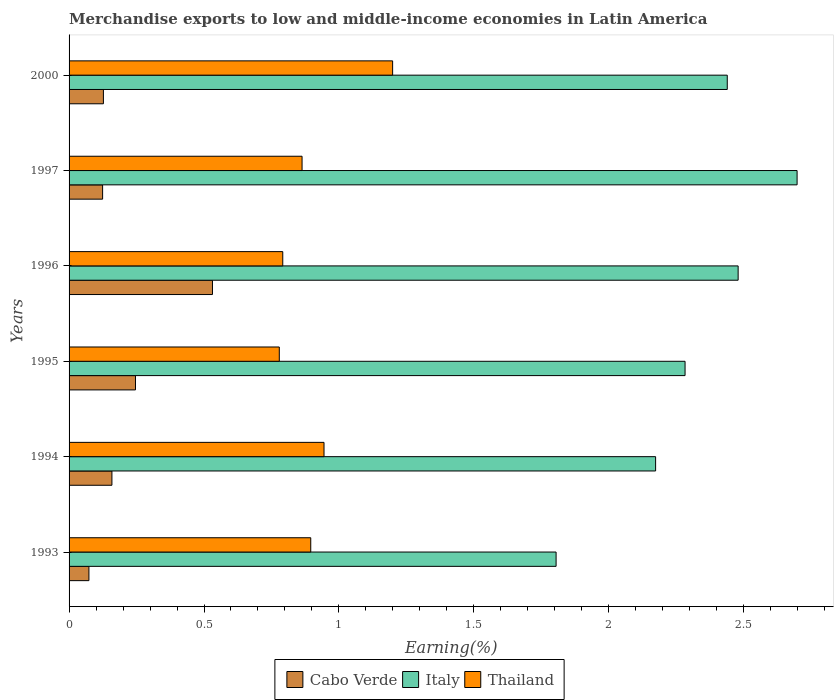How many bars are there on the 1st tick from the top?
Make the answer very short. 3. How many bars are there on the 6th tick from the bottom?
Your answer should be compact. 3. What is the label of the 6th group of bars from the top?
Ensure brevity in your answer.  1993. What is the percentage of amount earned from merchandise exports in Italy in 1996?
Your answer should be very brief. 2.48. Across all years, what is the maximum percentage of amount earned from merchandise exports in Italy?
Your answer should be compact. 2.7. Across all years, what is the minimum percentage of amount earned from merchandise exports in Cabo Verde?
Give a very brief answer. 0.07. In which year was the percentage of amount earned from merchandise exports in Thailand maximum?
Ensure brevity in your answer.  2000. In which year was the percentage of amount earned from merchandise exports in Italy minimum?
Give a very brief answer. 1993. What is the total percentage of amount earned from merchandise exports in Italy in the graph?
Provide a short and direct response. 13.88. What is the difference between the percentage of amount earned from merchandise exports in Cabo Verde in 1996 and that in 2000?
Your answer should be very brief. 0.4. What is the difference between the percentage of amount earned from merchandise exports in Italy in 1994 and the percentage of amount earned from merchandise exports in Cabo Verde in 2000?
Keep it short and to the point. 2.05. What is the average percentage of amount earned from merchandise exports in Cabo Verde per year?
Ensure brevity in your answer.  0.21. In the year 2000, what is the difference between the percentage of amount earned from merchandise exports in Italy and percentage of amount earned from merchandise exports in Cabo Verde?
Ensure brevity in your answer.  2.31. What is the ratio of the percentage of amount earned from merchandise exports in Cabo Verde in 1996 to that in 2000?
Offer a terse response. 4.18. Is the difference between the percentage of amount earned from merchandise exports in Italy in 1994 and 2000 greater than the difference between the percentage of amount earned from merchandise exports in Cabo Verde in 1994 and 2000?
Give a very brief answer. No. What is the difference between the highest and the second highest percentage of amount earned from merchandise exports in Cabo Verde?
Offer a very short reply. 0.29. What is the difference between the highest and the lowest percentage of amount earned from merchandise exports in Thailand?
Make the answer very short. 0.42. In how many years, is the percentage of amount earned from merchandise exports in Italy greater than the average percentage of amount earned from merchandise exports in Italy taken over all years?
Keep it short and to the point. 3. Is it the case that in every year, the sum of the percentage of amount earned from merchandise exports in Cabo Verde and percentage of amount earned from merchandise exports in Italy is greater than the percentage of amount earned from merchandise exports in Thailand?
Make the answer very short. Yes. Are all the bars in the graph horizontal?
Your answer should be very brief. Yes. Are the values on the major ticks of X-axis written in scientific E-notation?
Keep it short and to the point. No. What is the title of the graph?
Your answer should be compact. Merchandise exports to low and middle-income economies in Latin America. What is the label or title of the X-axis?
Your answer should be compact. Earning(%). What is the label or title of the Y-axis?
Make the answer very short. Years. What is the Earning(%) in Cabo Verde in 1993?
Ensure brevity in your answer.  0.07. What is the Earning(%) of Italy in 1993?
Provide a short and direct response. 1.8. What is the Earning(%) in Thailand in 1993?
Provide a succinct answer. 0.9. What is the Earning(%) of Cabo Verde in 1994?
Give a very brief answer. 0.16. What is the Earning(%) in Italy in 1994?
Give a very brief answer. 2.17. What is the Earning(%) of Thailand in 1994?
Provide a succinct answer. 0.94. What is the Earning(%) in Cabo Verde in 1995?
Your response must be concise. 0.25. What is the Earning(%) in Italy in 1995?
Offer a very short reply. 2.28. What is the Earning(%) in Thailand in 1995?
Keep it short and to the point. 0.78. What is the Earning(%) in Cabo Verde in 1996?
Provide a succinct answer. 0.53. What is the Earning(%) in Italy in 1996?
Offer a very short reply. 2.48. What is the Earning(%) of Thailand in 1996?
Offer a very short reply. 0.79. What is the Earning(%) in Cabo Verde in 1997?
Offer a very short reply. 0.12. What is the Earning(%) of Italy in 1997?
Your response must be concise. 2.7. What is the Earning(%) of Thailand in 1997?
Your answer should be very brief. 0.86. What is the Earning(%) in Cabo Verde in 2000?
Make the answer very short. 0.13. What is the Earning(%) in Italy in 2000?
Make the answer very short. 2.44. What is the Earning(%) in Thailand in 2000?
Make the answer very short. 1.2. Across all years, what is the maximum Earning(%) in Cabo Verde?
Offer a very short reply. 0.53. Across all years, what is the maximum Earning(%) of Italy?
Offer a terse response. 2.7. Across all years, what is the maximum Earning(%) of Thailand?
Provide a short and direct response. 1.2. Across all years, what is the minimum Earning(%) in Cabo Verde?
Offer a terse response. 0.07. Across all years, what is the minimum Earning(%) of Italy?
Keep it short and to the point. 1.8. Across all years, what is the minimum Earning(%) in Thailand?
Your response must be concise. 0.78. What is the total Earning(%) in Cabo Verde in the graph?
Give a very brief answer. 1.26. What is the total Earning(%) in Italy in the graph?
Offer a very short reply. 13.88. What is the total Earning(%) in Thailand in the graph?
Your answer should be very brief. 5.47. What is the difference between the Earning(%) of Cabo Verde in 1993 and that in 1994?
Give a very brief answer. -0.09. What is the difference between the Earning(%) in Italy in 1993 and that in 1994?
Your answer should be compact. -0.37. What is the difference between the Earning(%) of Thailand in 1993 and that in 1994?
Keep it short and to the point. -0.05. What is the difference between the Earning(%) in Cabo Verde in 1993 and that in 1995?
Offer a very short reply. -0.17. What is the difference between the Earning(%) of Italy in 1993 and that in 1995?
Provide a short and direct response. -0.48. What is the difference between the Earning(%) of Thailand in 1993 and that in 1995?
Your answer should be very brief. 0.12. What is the difference between the Earning(%) in Cabo Verde in 1993 and that in 1996?
Give a very brief answer. -0.46. What is the difference between the Earning(%) of Italy in 1993 and that in 1996?
Ensure brevity in your answer.  -0.67. What is the difference between the Earning(%) in Thailand in 1993 and that in 1996?
Give a very brief answer. 0.1. What is the difference between the Earning(%) of Cabo Verde in 1993 and that in 1997?
Make the answer very short. -0.05. What is the difference between the Earning(%) in Italy in 1993 and that in 1997?
Provide a short and direct response. -0.89. What is the difference between the Earning(%) in Thailand in 1993 and that in 1997?
Make the answer very short. 0.03. What is the difference between the Earning(%) of Cabo Verde in 1993 and that in 2000?
Ensure brevity in your answer.  -0.05. What is the difference between the Earning(%) in Italy in 1993 and that in 2000?
Keep it short and to the point. -0.63. What is the difference between the Earning(%) in Thailand in 1993 and that in 2000?
Your response must be concise. -0.3. What is the difference between the Earning(%) of Cabo Verde in 1994 and that in 1995?
Your response must be concise. -0.09. What is the difference between the Earning(%) in Italy in 1994 and that in 1995?
Your answer should be very brief. -0.11. What is the difference between the Earning(%) of Thailand in 1994 and that in 1995?
Give a very brief answer. 0.17. What is the difference between the Earning(%) in Cabo Verde in 1994 and that in 1996?
Offer a terse response. -0.37. What is the difference between the Earning(%) of Italy in 1994 and that in 1996?
Provide a short and direct response. -0.31. What is the difference between the Earning(%) of Thailand in 1994 and that in 1996?
Provide a short and direct response. 0.15. What is the difference between the Earning(%) in Cabo Verde in 1994 and that in 1997?
Offer a terse response. 0.03. What is the difference between the Earning(%) of Italy in 1994 and that in 1997?
Provide a succinct answer. -0.52. What is the difference between the Earning(%) of Thailand in 1994 and that in 1997?
Ensure brevity in your answer.  0.08. What is the difference between the Earning(%) of Cabo Verde in 1994 and that in 2000?
Your answer should be compact. 0.03. What is the difference between the Earning(%) of Italy in 1994 and that in 2000?
Your answer should be compact. -0.27. What is the difference between the Earning(%) in Thailand in 1994 and that in 2000?
Keep it short and to the point. -0.25. What is the difference between the Earning(%) of Cabo Verde in 1995 and that in 1996?
Provide a short and direct response. -0.29. What is the difference between the Earning(%) of Italy in 1995 and that in 1996?
Provide a succinct answer. -0.2. What is the difference between the Earning(%) of Thailand in 1995 and that in 1996?
Provide a succinct answer. -0.01. What is the difference between the Earning(%) in Cabo Verde in 1995 and that in 1997?
Keep it short and to the point. 0.12. What is the difference between the Earning(%) of Italy in 1995 and that in 1997?
Offer a very short reply. -0.42. What is the difference between the Earning(%) in Thailand in 1995 and that in 1997?
Your answer should be very brief. -0.08. What is the difference between the Earning(%) of Cabo Verde in 1995 and that in 2000?
Give a very brief answer. 0.12. What is the difference between the Earning(%) of Italy in 1995 and that in 2000?
Provide a short and direct response. -0.16. What is the difference between the Earning(%) of Thailand in 1995 and that in 2000?
Give a very brief answer. -0.42. What is the difference between the Earning(%) of Cabo Verde in 1996 and that in 1997?
Give a very brief answer. 0.41. What is the difference between the Earning(%) of Italy in 1996 and that in 1997?
Offer a terse response. -0.22. What is the difference between the Earning(%) in Thailand in 1996 and that in 1997?
Provide a short and direct response. -0.07. What is the difference between the Earning(%) of Cabo Verde in 1996 and that in 2000?
Make the answer very short. 0.4. What is the difference between the Earning(%) in Italy in 1996 and that in 2000?
Provide a short and direct response. 0.04. What is the difference between the Earning(%) in Thailand in 1996 and that in 2000?
Offer a very short reply. -0.41. What is the difference between the Earning(%) of Cabo Verde in 1997 and that in 2000?
Keep it short and to the point. -0. What is the difference between the Earning(%) in Italy in 1997 and that in 2000?
Offer a terse response. 0.26. What is the difference between the Earning(%) of Thailand in 1997 and that in 2000?
Make the answer very short. -0.34. What is the difference between the Earning(%) of Cabo Verde in 1993 and the Earning(%) of Thailand in 1994?
Provide a succinct answer. -0.87. What is the difference between the Earning(%) of Italy in 1993 and the Earning(%) of Thailand in 1994?
Provide a succinct answer. 0.86. What is the difference between the Earning(%) in Cabo Verde in 1993 and the Earning(%) in Italy in 1995?
Provide a succinct answer. -2.21. What is the difference between the Earning(%) in Cabo Verde in 1993 and the Earning(%) in Thailand in 1995?
Offer a very short reply. -0.71. What is the difference between the Earning(%) in Italy in 1993 and the Earning(%) in Thailand in 1995?
Make the answer very short. 1.03. What is the difference between the Earning(%) of Cabo Verde in 1993 and the Earning(%) of Italy in 1996?
Offer a terse response. -2.41. What is the difference between the Earning(%) of Cabo Verde in 1993 and the Earning(%) of Thailand in 1996?
Offer a terse response. -0.72. What is the difference between the Earning(%) in Italy in 1993 and the Earning(%) in Thailand in 1996?
Offer a terse response. 1.01. What is the difference between the Earning(%) in Cabo Verde in 1993 and the Earning(%) in Italy in 1997?
Provide a short and direct response. -2.62. What is the difference between the Earning(%) of Cabo Verde in 1993 and the Earning(%) of Thailand in 1997?
Keep it short and to the point. -0.79. What is the difference between the Earning(%) in Italy in 1993 and the Earning(%) in Thailand in 1997?
Offer a very short reply. 0.94. What is the difference between the Earning(%) of Cabo Verde in 1993 and the Earning(%) of Italy in 2000?
Your response must be concise. -2.37. What is the difference between the Earning(%) in Cabo Verde in 1993 and the Earning(%) in Thailand in 2000?
Your response must be concise. -1.13. What is the difference between the Earning(%) of Italy in 1993 and the Earning(%) of Thailand in 2000?
Provide a succinct answer. 0.61. What is the difference between the Earning(%) in Cabo Verde in 1994 and the Earning(%) in Italy in 1995?
Keep it short and to the point. -2.12. What is the difference between the Earning(%) in Cabo Verde in 1994 and the Earning(%) in Thailand in 1995?
Make the answer very short. -0.62. What is the difference between the Earning(%) of Italy in 1994 and the Earning(%) of Thailand in 1995?
Provide a short and direct response. 1.39. What is the difference between the Earning(%) of Cabo Verde in 1994 and the Earning(%) of Italy in 1996?
Provide a succinct answer. -2.32. What is the difference between the Earning(%) in Cabo Verde in 1994 and the Earning(%) in Thailand in 1996?
Your answer should be very brief. -0.63. What is the difference between the Earning(%) of Italy in 1994 and the Earning(%) of Thailand in 1996?
Make the answer very short. 1.38. What is the difference between the Earning(%) in Cabo Verde in 1994 and the Earning(%) in Italy in 1997?
Give a very brief answer. -2.54. What is the difference between the Earning(%) of Cabo Verde in 1994 and the Earning(%) of Thailand in 1997?
Give a very brief answer. -0.7. What is the difference between the Earning(%) of Italy in 1994 and the Earning(%) of Thailand in 1997?
Make the answer very short. 1.31. What is the difference between the Earning(%) of Cabo Verde in 1994 and the Earning(%) of Italy in 2000?
Your answer should be very brief. -2.28. What is the difference between the Earning(%) of Cabo Verde in 1994 and the Earning(%) of Thailand in 2000?
Your answer should be compact. -1.04. What is the difference between the Earning(%) in Italy in 1994 and the Earning(%) in Thailand in 2000?
Provide a succinct answer. 0.97. What is the difference between the Earning(%) of Cabo Verde in 1995 and the Earning(%) of Italy in 1996?
Offer a very short reply. -2.23. What is the difference between the Earning(%) in Cabo Verde in 1995 and the Earning(%) in Thailand in 1996?
Ensure brevity in your answer.  -0.55. What is the difference between the Earning(%) of Italy in 1995 and the Earning(%) of Thailand in 1996?
Make the answer very short. 1.49. What is the difference between the Earning(%) of Cabo Verde in 1995 and the Earning(%) of Italy in 1997?
Your answer should be compact. -2.45. What is the difference between the Earning(%) in Cabo Verde in 1995 and the Earning(%) in Thailand in 1997?
Offer a very short reply. -0.62. What is the difference between the Earning(%) in Italy in 1995 and the Earning(%) in Thailand in 1997?
Your answer should be very brief. 1.42. What is the difference between the Earning(%) of Cabo Verde in 1995 and the Earning(%) of Italy in 2000?
Your answer should be compact. -2.19. What is the difference between the Earning(%) in Cabo Verde in 1995 and the Earning(%) in Thailand in 2000?
Give a very brief answer. -0.95. What is the difference between the Earning(%) in Italy in 1995 and the Earning(%) in Thailand in 2000?
Give a very brief answer. 1.08. What is the difference between the Earning(%) of Cabo Verde in 1996 and the Earning(%) of Italy in 1997?
Keep it short and to the point. -2.17. What is the difference between the Earning(%) of Cabo Verde in 1996 and the Earning(%) of Thailand in 1997?
Provide a short and direct response. -0.33. What is the difference between the Earning(%) of Italy in 1996 and the Earning(%) of Thailand in 1997?
Give a very brief answer. 1.62. What is the difference between the Earning(%) of Cabo Verde in 1996 and the Earning(%) of Italy in 2000?
Your answer should be very brief. -1.91. What is the difference between the Earning(%) in Cabo Verde in 1996 and the Earning(%) in Thailand in 2000?
Keep it short and to the point. -0.67. What is the difference between the Earning(%) in Italy in 1996 and the Earning(%) in Thailand in 2000?
Provide a short and direct response. 1.28. What is the difference between the Earning(%) of Cabo Verde in 1997 and the Earning(%) of Italy in 2000?
Your answer should be very brief. -2.31. What is the difference between the Earning(%) in Cabo Verde in 1997 and the Earning(%) in Thailand in 2000?
Keep it short and to the point. -1.07. What is the difference between the Earning(%) in Italy in 1997 and the Earning(%) in Thailand in 2000?
Keep it short and to the point. 1.5. What is the average Earning(%) of Cabo Verde per year?
Ensure brevity in your answer.  0.21. What is the average Earning(%) of Italy per year?
Your answer should be compact. 2.31. What is the average Earning(%) of Thailand per year?
Provide a succinct answer. 0.91. In the year 1993, what is the difference between the Earning(%) of Cabo Verde and Earning(%) of Italy?
Your answer should be compact. -1.73. In the year 1993, what is the difference between the Earning(%) of Cabo Verde and Earning(%) of Thailand?
Provide a succinct answer. -0.82. In the year 1993, what is the difference between the Earning(%) of Italy and Earning(%) of Thailand?
Offer a very short reply. 0.91. In the year 1994, what is the difference between the Earning(%) in Cabo Verde and Earning(%) in Italy?
Keep it short and to the point. -2.01. In the year 1994, what is the difference between the Earning(%) in Cabo Verde and Earning(%) in Thailand?
Your response must be concise. -0.79. In the year 1994, what is the difference between the Earning(%) in Italy and Earning(%) in Thailand?
Offer a very short reply. 1.23. In the year 1995, what is the difference between the Earning(%) in Cabo Verde and Earning(%) in Italy?
Provide a succinct answer. -2.04. In the year 1995, what is the difference between the Earning(%) of Cabo Verde and Earning(%) of Thailand?
Ensure brevity in your answer.  -0.53. In the year 1995, what is the difference between the Earning(%) of Italy and Earning(%) of Thailand?
Provide a short and direct response. 1.5. In the year 1996, what is the difference between the Earning(%) in Cabo Verde and Earning(%) in Italy?
Provide a short and direct response. -1.95. In the year 1996, what is the difference between the Earning(%) of Cabo Verde and Earning(%) of Thailand?
Your answer should be very brief. -0.26. In the year 1996, what is the difference between the Earning(%) of Italy and Earning(%) of Thailand?
Your answer should be compact. 1.69. In the year 1997, what is the difference between the Earning(%) of Cabo Verde and Earning(%) of Italy?
Your response must be concise. -2.57. In the year 1997, what is the difference between the Earning(%) in Cabo Verde and Earning(%) in Thailand?
Provide a succinct answer. -0.74. In the year 1997, what is the difference between the Earning(%) of Italy and Earning(%) of Thailand?
Provide a succinct answer. 1.83. In the year 2000, what is the difference between the Earning(%) of Cabo Verde and Earning(%) of Italy?
Make the answer very short. -2.31. In the year 2000, what is the difference between the Earning(%) in Cabo Verde and Earning(%) in Thailand?
Your answer should be very brief. -1.07. In the year 2000, what is the difference between the Earning(%) of Italy and Earning(%) of Thailand?
Your answer should be very brief. 1.24. What is the ratio of the Earning(%) of Cabo Verde in 1993 to that in 1994?
Your answer should be very brief. 0.46. What is the ratio of the Earning(%) of Italy in 1993 to that in 1994?
Give a very brief answer. 0.83. What is the ratio of the Earning(%) of Thailand in 1993 to that in 1994?
Provide a succinct answer. 0.95. What is the ratio of the Earning(%) of Cabo Verde in 1993 to that in 1995?
Keep it short and to the point. 0.3. What is the ratio of the Earning(%) of Italy in 1993 to that in 1995?
Provide a short and direct response. 0.79. What is the ratio of the Earning(%) in Thailand in 1993 to that in 1995?
Offer a terse response. 1.15. What is the ratio of the Earning(%) of Cabo Verde in 1993 to that in 1996?
Provide a succinct answer. 0.14. What is the ratio of the Earning(%) of Italy in 1993 to that in 1996?
Provide a short and direct response. 0.73. What is the ratio of the Earning(%) in Thailand in 1993 to that in 1996?
Keep it short and to the point. 1.13. What is the ratio of the Earning(%) of Cabo Verde in 1993 to that in 1997?
Offer a very short reply. 0.59. What is the ratio of the Earning(%) in Italy in 1993 to that in 1997?
Your response must be concise. 0.67. What is the ratio of the Earning(%) of Thailand in 1993 to that in 1997?
Your response must be concise. 1.04. What is the ratio of the Earning(%) of Cabo Verde in 1993 to that in 2000?
Offer a very short reply. 0.58. What is the ratio of the Earning(%) in Italy in 1993 to that in 2000?
Make the answer very short. 0.74. What is the ratio of the Earning(%) in Thailand in 1993 to that in 2000?
Your answer should be very brief. 0.75. What is the ratio of the Earning(%) in Cabo Verde in 1994 to that in 1995?
Your answer should be compact. 0.65. What is the ratio of the Earning(%) in Italy in 1994 to that in 1995?
Make the answer very short. 0.95. What is the ratio of the Earning(%) in Thailand in 1994 to that in 1995?
Make the answer very short. 1.21. What is the ratio of the Earning(%) of Cabo Verde in 1994 to that in 1996?
Provide a short and direct response. 0.3. What is the ratio of the Earning(%) in Italy in 1994 to that in 1996?
Provide a short and direct response. 0.88. What is the ratio of the Earning(%) of Thailand in 1994 to that in 1996?
Ensure brevity in your answer.  1.19. What is the ratio of the Earning(%) of Cabo Verde in 1994 to that in 1997?
Provide a short and direct response. 1.28. What is the ratio of the Earning(%) in Italy in 1994 to that in 1997?
Ensure brevity in your answer.  0.81. What is the ratio of the Earning(%) of Thailand in 1994 to that in 1997?
Keep it short and to the point. 1.09. What is the ratio of the Earning(%) in Cabo Verde in 1994 to that in 2000?
Offer a terse response. 1.25. What is the ratio of the Earning(%) in Italy in 1994 to that in 2000?
Give a very brief answer. 0.89. What is the ratio of the Earning(%) in Thailand in 1994 to that in 2000?
Make the answer very short. 0.79. What is the ratio of the Earning(%) of Cabo Verde in 1995 to that in 1996?
Offer a very short reply. 0.46. What is the ratio of the Earning(%) of Italy in 1995 to that in 1996?
Give a very brief answer. 0.92. What is the ratio of the Earning(%) of Thailand in 1995 to that in 1996?
Provide a short and direct response. 0.98. What is the ratio of the Earning(%) of Cabo Verde in 1995 to that in 1997?
Give a very brief answer. 1.98. What is the ratio of the Earning(%) in Italy in 1995 to that in 1997?
Offer a terse response. 0.85. What is the ratio of the Earning(%) of Thailand in 1995 to that in 1997?
Keep it short and to the point. 0.9. What is the ratio of the Earning(%) of Cabo Verde in 1995 to that in 2000?
Offer a terse response. 1.93. What is the ratio of the Earning(%) in Italy in 1995 to that in 2000?
Keep it short and to the point. 0.94. What is the ratio of the Earning(%) in Thailand in 1995 to that in 2000?
Offer a very short reply. 0.65. What is the ratio of the Earning(%) in Cabo Verde in 1996 to that in 1997?
Keep it short and to the point. 4.28. What is the ratio of the Earning(%) in Italy in 1996 to that in 1997?
Your answer should be very brief. 0.92. What is the ratio of the Earning(%) in Thailand in 1996 to that in 1997?
Your answer should be compact. 0.92. What is the ratio of the Earning(%) in Cabo Verde in 1996 to that in 2000?
Offer a terse response. 4.18. What is the ratio of the Earning(%) in Italy in 1996 to that in 2000?
Make the answer very short. 1.02. What is the ratio of the Earning(%) in Thailand in 1996 to that in 2000?
Offer a terse response. 0.66. What is the ratio of the Earning(%) of Cabo Verde in 1997 to that in 2000?
Make the answer very short. 0.98. What is the ratio of the Earning(%) of Italy in 1997 to that in 2000?
Give a very brief answer. 1.11. What is the ratio of the Earning(%) in Thailand in 1997 to that in 2000?
Make the answer very short. 0.72. What is the difference between the highest and the second highest Earning(%) of Cabo Verde?
Provide a short and direct response. 0.29. What is the difference between the highest and the second highest Earning(%) of Italy?
Ensure brevity in your answer.  0.22. What is the difference between the highest and the second highest Earning(%) of Thailand?
Offer a very short reply. 0.25. What is the difference between the highest and the lowest Earning(%) of Cabo Verde?
Keep it short and to the point. 0.46. What is the difference between the highest and the lowest Earning(%) in Italy?
Your answer should be compact. 0.89. What is the difference between the highest and the lowest Earning(%) in Thailand?
Offer a terse response. 0.42. 